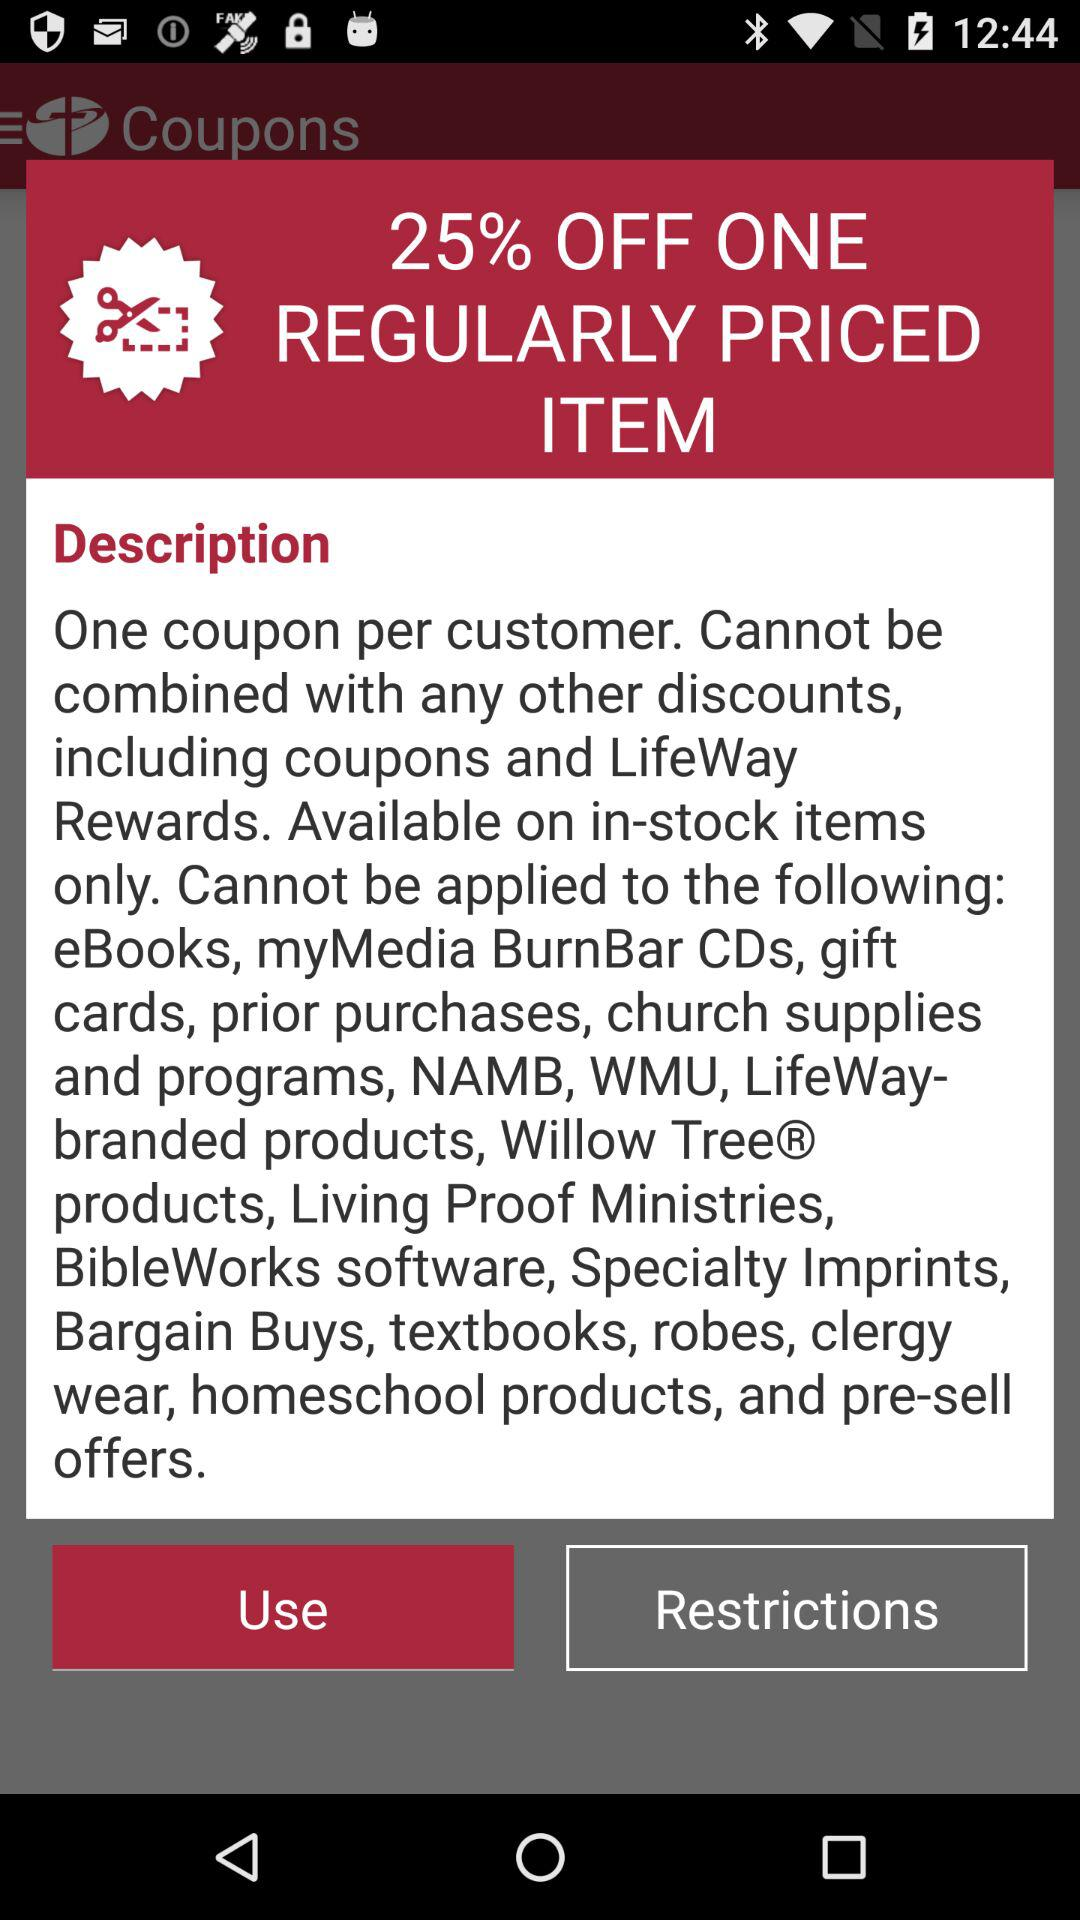What is the discount on one regularly priced item? The discount on one regularly priced item is 25%. 